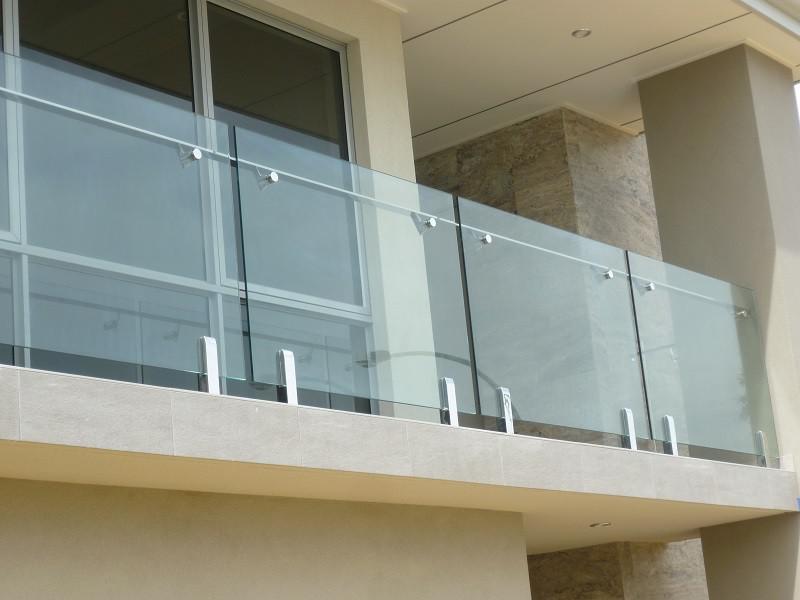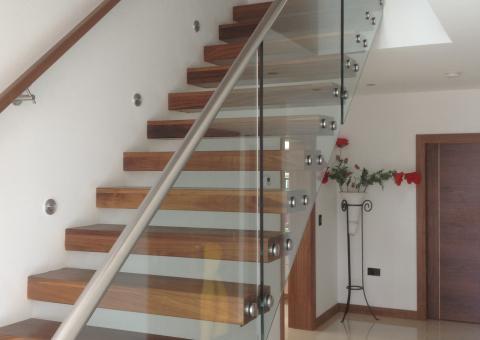The first image is the image on the left, the second image is the image on the right. Evaluate the accuracy of this statement regarding the images: "One image shows a glass-paneled balcony in a white building, and the other shows a glass-paneled staircase railing next to brown wood steps.". Is it true? Answer yes or no. Yes. The first image is the image on the left, the second image is the image on the right. For the images shown, is this caption "In one image the sky and clouds are visible." true? Answer yes or no. No. 